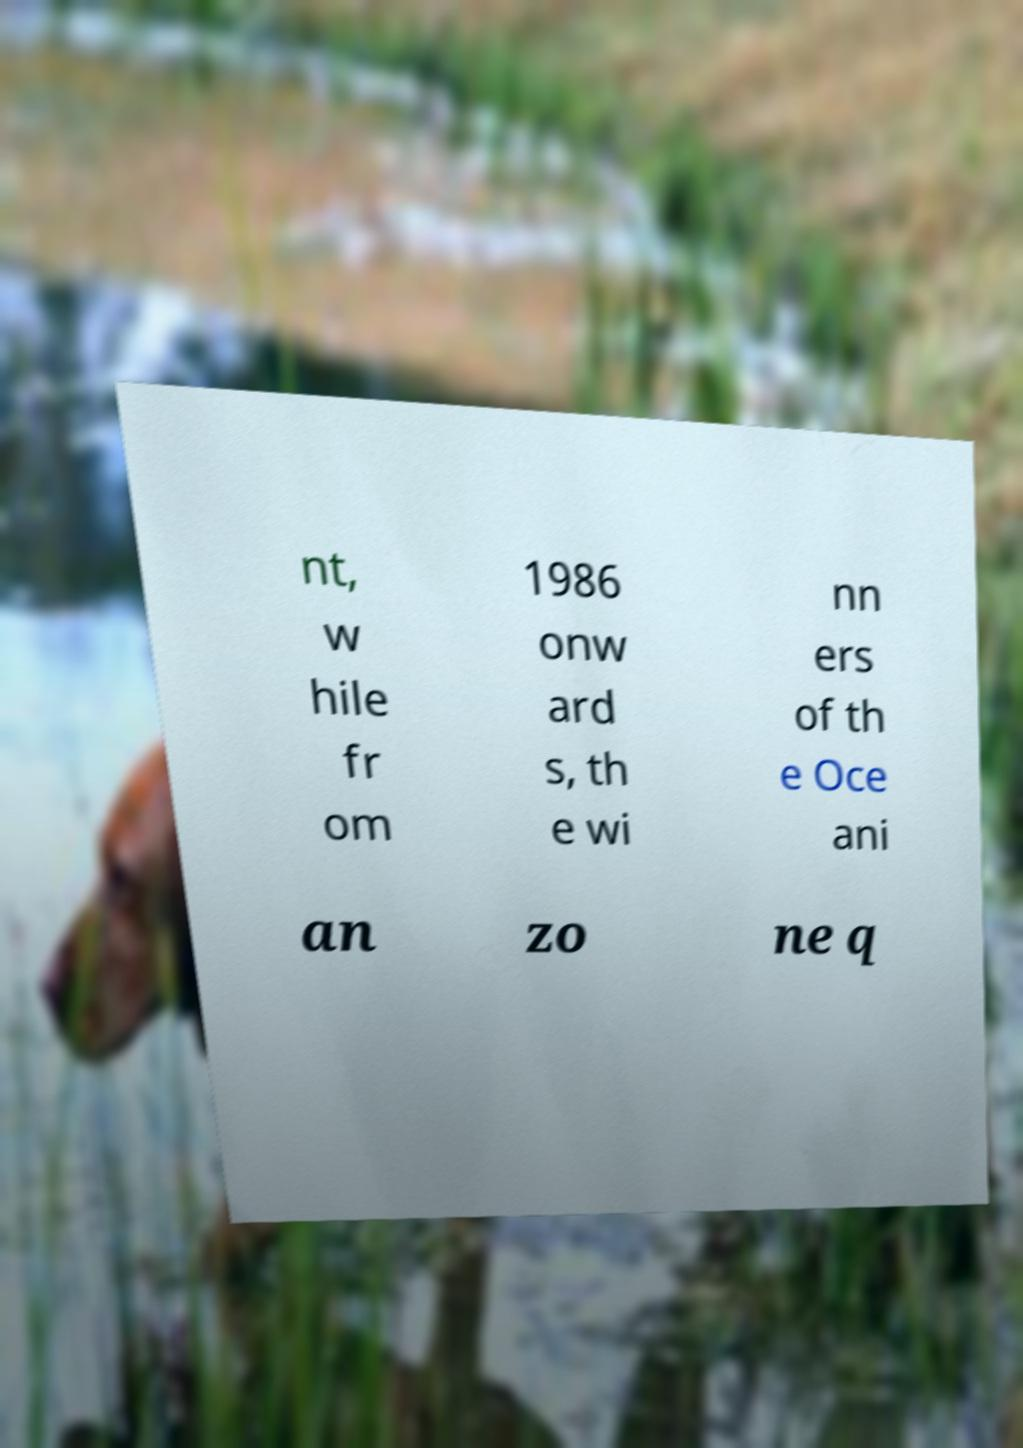For documentation purposes, I need the text within this image transcribed. Could you provide that? nt, w hile fr om 1986 onw ard s, th e wi nn ers of th e Oce ani an zo ne q 